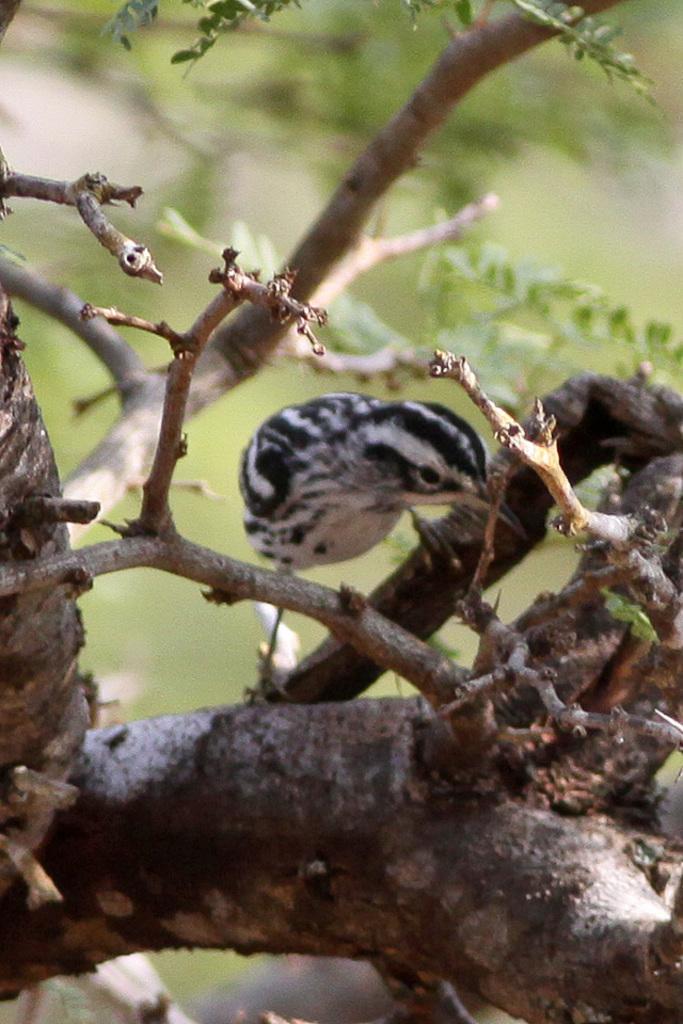Can you describe this image briefly? In the picture I can see a bird which is in black and white is on the tree branch. The background of the image is blurred, which is in green color. 